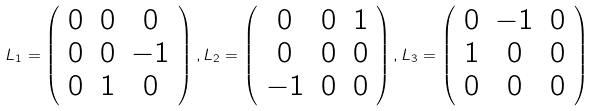Convert formula to latex. <formula><loc_0><loc_0><loc_500><loc_500>L _ { 1 } = \left ( \begin{array} [ c ] { c c c } 0 & 0 & 0 \\ 0 & 0 & - 1 \\ 0 & 1 & 0 \end{array} \right ) , L _ { 2 } = \left ( \begin{array} [ c ] { c c c } 0 & 0 & 1 \\ 0 & 0 & 0 \\ - 1 & 0 & 0 \end{array} \right ) , L _ { 3 } = \left ( \begin{array} [ c ] { c c c } 0 & - 1 & 0 \\ 1 & 0 & 0 \\ 0 & 0 & 0 \end{array} \right )</formula> 